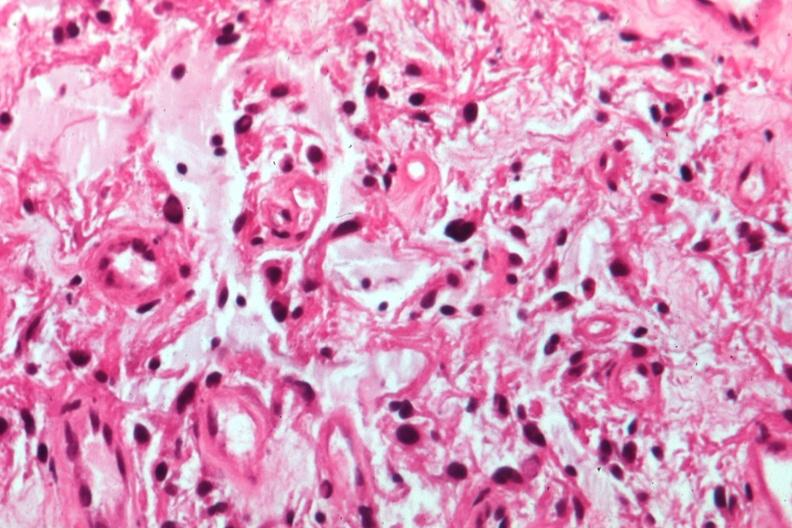s 70yof present?
Answer the question using a single word or phrase. No 